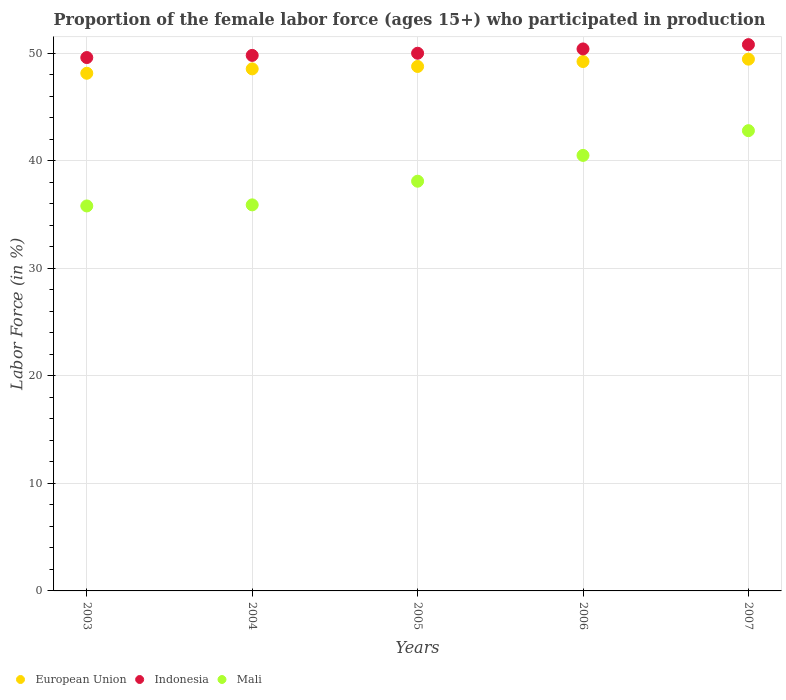How many different coloured dotlines are there?
Provide a short and direct response. 3. What is the proportion of the female labor force who participated in production in European Union in 2003?
Provide a short and direct response. 48.14. Across all years, what is the maximum proportion of the female labor force who participated in production in European Union?
Your answer should be very brief. 49.45. Across all years, what is the minimum proportion of the female labor force who participated in production in European Union?
Keep it short and to the point. 48.14. In which year was the proportion of the female labor force who participated in production in Mali maximum?
Make the answer very short. 2007. What is the total proportion of the female labor force who participated in production in Mali in the graph?
Your answer should be very brief. 193.1. What is the difference between the proportion of the female labor force who participated in production in Mali in 2003 and that in 2006?
Provide a short and direct response. -4.7. What is the difference between the proportion of the female labor force who participated in production in European Union in 2005 and the proportion of the female labor force who participated in production in Indonesia in 2007?
Give a very brief answer. -2.03. What is the average proportion of the female labor force who participated in production in Mali per year?
Your response must be concise. 38.62. In the year 2004, what is the difference between the proportion of the female labor force who participated in production in Indonesia and proportion of the female labor force who participated in production in Mali?
Provide a succinct answer. 13.9. In how many years, is the proportion of the female labor force who participated in production in European Union greater than 22 %?
Offer a very short reply. 5. What is the ratio of the proportion of the female labor force who participated in production in European Union in 2004 to that in 2005?
Provide a succinct answer. 1. Is the difference between the proportion of the female labor force who participated in production in Indonesia in 2005 and 2007 greater than the difference between the proportion of the female labor force who participated in production in Mali in 2005 and 2007?
Keep it short and to the point. Yes. What is the difference between the highest and the second highest proportion of the female labor force who participated in production in Mali?
Provide a succinct answer. 2.3. What is the difference between the highest and the lowest proportion of the female labor force who participated in production in European Union?
Keep it short and to the point. 1.31. Does the proportion of the female labor force who participated in production in European Union monotonically increase over the years?
Ensure brevity in your answer.  Yes. Is the proportion of the female labor force who participated in production in European Union strictly less than the proportion of the female labor force who participated in production in Indonesia over the years?
Provide a short and direct response. Yes. How many years are there in the graph?
Give a very brief answer. 5. What is the difference between two consecutive major ticks on the Y-axis?
Keep it short and to the point. 10. Are the values on the major ticks of Y-axis written in scientific E-notation?
Offer a very short reply. No. Does the graph contain any zero values?
Give a very brief answer. No. How are the legend labels stacked?
Make the answer very short. Horizontal. What is the title of the graph?
Ensure brevity in your answer.  Proportion of the female labor force (ages 15+) who participated in production. What is the label or title of the X-axis?
Provide a succinct answer. Years. What is the Labor Force (in %) of European Union in 2003?
Make the answer very short. 48.14. What is the Labor Force (in %) in Indonesia in 2003?
Give a very brief answer. 49.6. What is the Labor Force (in %) in Mali in 2003?
Your answer should be very brief. 35.8. What is the Labor Force (in %) in European Union in 2004?
Provide a short and direct response. 48.55. What is the Labor Force (in %) in Indonesia in 2004?
Offer a very short reply. 49.8. What is the Labor Force (in %) of Mali in 2004?
Give a very brief answer. 35.9. What is the Labor Force (in %) in European Union in 2005?
Your answer should be compact. 48.77. What is the Labor Force (in %) of Indonesia in 2005?
Offer a terse response. 50. What is the Labor Force (in %) in Mali in 2005?
Offer a terse response. 38.1. What is the Labor Force (in %) of European Union in 2006?
Your answer should be compact. 49.23. What is the Labor Force (in %) of Indonesia in 2006?
Keep it short and to the point. 50.4. What is the Labor Force (in %) of Mali in 2006?
Offer a very short reply. 40.5. What is the Labor Force (in %) in European Union in 2007?
Your answer should be compact. 49.45. What is the Labor Force (in %) of Indonesia in 2007?
Offer a terse response. 50.8. What is the Labor Force (in %) of Mali in 2007?
Ensure brevity in your answer.  42.8. Across all years, what is the maximum Labor Force (in %) of European Union?
Make the answer very short. 49.45. Across all years, what is the maximum Labor Force (in %) in Indonesia?
Your response must be concise. 50.8. Across all years, what is the maximum Labor Force (in %) in Mali?
Your response must be concise. 42.8. Across all years, what is the minimum Labor Force (in %) in European Union?
Your answer should be compact. 48.14. Across all years, what is the minimum Labor Force (in %) in Indonesia?
Make the answer very short. 49.6. Across all years, what is the minimum Labor Force (in %) of Mali?
Provide a short and direct response. 35.8. What is the total Labor Force (in %) of European Union in the graph?
Ensure brevity in your answer.  244.14. What is the total Labor Force (in %) of Indonesia in the graph?
Provide a succinct answer. 250.6. What is the total Labor Force (in %) in Mali in the graph?
Your answer should be compact. 193.1. What is the difference between the Labor Force (in %) of European Union in 2003 and that in 2004?
Provide a succinct answer. -0.41. What is the difference between the Labor Force (in %) in Indonesia in 2003 and that in 2004?
Your response must be concise. -0.2. What is the difference between the Labor Force (in %) of European Union in 2003 and that in 2005?
Offer a very short reply. -0.63. What is the difference between the Labor Force (in %) of Indonesia in 2003 and that in 2005?
Provide a succinct answer. -0.4. What is the difference between the Labor Force (in %) in Mali in 2003 and that in 2005?
Your response must be concise. -2.3. What is the difference between the Labor Force (in %) of European Union in 2003 and that in 2006?
Give a very brief answer. -1.09. What is the difference between the Labor Force (in %) of Mali in 2003 and that in 2006?
Give a very brief answer. -4.7. What is the difference between the Labor Force (in %) in European Union in 2003 and that in 2007?
Offer a very short reply. -1.31. What is the difference between the Labor Force (in %) in European Union in 2004 and that in 2005?
Provide a succinct answer. -0.22. What is the difference between the Labor Force (in %) in Mali in 2004 and that in 2005?
Your response must be concise. -2.2. What is the difference between the Labor Force (in %) in European Union in 2004 and that in 2006?
Make the answer very short. -0.68. What is the difference between the Labor Force (in %) of Indonesia in 2004 and that in 2006?
Offer a terse response. -0.6. What is the difference between the Labor Force (in %) in Mali in 2004 and that in 2006?
Offer a very short reply. -4.6. What is the difference between the Labor Force (in %) in European Union in 2004 and that in 2007?
Make the answer very short. -0.9. What is the difference between the Labor Force (in %) in Mali in 2004 and that in 2007?
Keep it short and to the point. -6.9. What is the difference between the Labor Force (in %) in European Union in 2005 and that in 2006?
Provide a succinct answer. -0.46. What is the difference between the Labor Force (in %) of Indonesia in 2005 and that in 2006?
Your response must be concise. -0.4. What is the difference between the Labor Force (in %) in European Union in 2005 and that in 2007?
Ensure brevity in your answer.  -0.68. What is the difference between the Labor Force (in %) of European Union in 2006 and that in 2007?
Ensure brevity in your answer.  -0.22. What is the difference between the Labor Force (in %) of European Union in 2003 and the Labor Force (in %) of Indonesia in 2004?
Your answer should be compact. -1.66. What is the difference between the Labor Force (in %) in European Union in 2003 and the Labor Force (in %) in Mali in 2004?
Offer a terse response. 12.24. What is the difference between the Labor Force (in %) in Indonesia in 2003 and the Labor Force (in %) in Mali in 2004?
Give a very brief answer. 13.7. What is the difference between the Labor Force (in %) in European Union in 2003 and the Labor Force (in %) in Indonesia in 2005?
Give a very brief answer. -1.86. What is the difference between the Labor Force (in %) in European Union in 2003 and the Labor Force (in %) in Mali in 2005?
Ensure brevity in your answer.  10.04. What is the difference between the Labor Force (in %) of Indonesia in 2003 and the Labor Force (in %) of Mali in 2005?
Provide a succinct answer. 11.5. What is the difference between the Labor Force (in %) of European Union in 2003 and the Labor Force (in %) of Indonesia in 2006?
Ensure brevity in your answer.  -2.26. What is the difference between the Labor Force (in %) in European Union in 2003 and the Labor Force (in %) in Mali in 2006?
Offer a terse response. 7.64. What is the difference between the Labor Force (in %) in Indonesia in 2003 and the Labor Force (in %) in Mali in 2006?
Provide a short and direct response. 9.1. What is the difference between the Labor Force (in %) of European Union in 2003 and the Labor Force (in %) of Indonesia in 2007?
Keep it short and to the point. -2.66. What is the difference between the Labor Force (in %) in European Union in 2003 and the Labor Force (in %) in Mali in 2007?
Your answer should be very brief. 5.34. What is the difference between the Labor Force (in %) in Indonesia in 2003 and the Labor Force (in %) in Mali in 2007?
Offer a very short reply. 6.8. What is the difference between the Labor Force (in %) in European Union in 2004 and the Labor Force (in %) in Indonesia in 2005?
Ensure brevity in your answer.  -1.45. What is the difference between the Labor Force (in %) in European Union in 2004 and the Labor Force (in %) in Mali in 2005?
Offer a very short reply. 10.45. What is the difference between the Labor Force (in %) in Indonesia in 2004 and the Labor Force (in %) in Mali in 2005?
Your answer should be compact. 11.7. What is the difference between the Labor Force (in %) in European Union in 2004 and the Labor Force (in %) in Indonesia in 2006?
Ensure brevity in your answer.  -1.85. What is the difference between the Labor Force (in %) of European Union in 2004 and the Labor Force (in %) of Mali in 2006?
Provide a short and direct response. 8.05. What is the difference between the Labor Force (in %) of Indonesia in 2004 and the Labor Force (in %) of Mali in 2006?
Make the answer very short. 9.3. What is the difference between the Labor Force (in %) of European Union in 2004 and the Labor Force (in %) of Indonesia in 2007?
Your answer should be very brief. -2.25. What is the difference between the Labor Force (in %) of European Union in 2004 and the Labor Force (in %) of Mali in 2007?
Ensure brevity in your answer.  5.75. What is the difference between the Labor Force (in %) of European Union in 2005 and the Labor Force (in %) of Indonesia in 2006?
Keep it short and to the point. -1.63. What is the difference between the Labor Force (in %) of European Union in 2005 and the Labor Force (in %) of Mali in 2006?
Offer a very short reply. 8.27. What is the difference between the Labor Force (in %) in Indonesia in 2005 and the Labor Force (in %) in Mali in 2006?
Provide a succinct answer. 9.5. What is the difference between the Labor Force (in %) in European Union in 2005 and the Labor Force (in %) in Indonesia in 2007?
Your response must be concise. -2.03. What is the difference between the Labor Force (in %) of European Union in 2005 and the Labor Force (in %) of Mali in 2007?
Offer a terse response. 5.97. What is the difference between the Labor Force (in %) in Indonesia in 2005 and the Labor Force (in %) in Mali in 2007?
Ensure brevity in your answer.  7.2. What is the difference between the Labor Force (in %) of European Union in 2006 and the Labor Force (in %) of Indonesia in 2007?
Your response must be concise. -1.57. What is the difference between the Labor Force (in %) of European Union in 2006 and the Labor Force (in %) of Mali in 2007?
Keep it short and to the point. 6.43. What is the difference between the Labor Force (in %) of Indonesia in 2006 and the Labor Force (in %) of Mali in 2007?
Provide a short and direct response. 7.6. What is the average Labor Force (in %) of European Union per year?
Your answer should be compact. 48.83. What is the average Labor Force (in %) of Indonesia per year?
Your response must be concise. 50.12. What is the average Labor Force (in %) of Mali per year?
Make the answer very short. 38.62. In the year 2003, what is the difference between the Labor Force (in %) in European Union and Labor Force (in %) in Indonesia?
Keep it short and to the point. -1.46. In the year 2003, what is the difference between the Labor Force (in %) of European Union and Labor Force (in %) of Mali?
Your response must be concise. 12.34. In the year 2003, what is the difference between the Labor Force (in %) of Indonesia and Labor Force (in %) of Mali?
Make the answer very short. 13.8. In the year 2004, what is the difference between the Labor Force (in %) in European Union and Labor Force (in %) in Indonesia?
Offer a terse response. -1.25. In the year 2004, what is the difference between the Labor Force (in %) in European Union and Labor Force (in %) in Mali?
Your response must be concise. 12.65. In the year 2004, what is the difference between the Labor Force (in %) in Indonesia and Labor Force (in %) in Mali?
Provide a succinct answer. 13.9. In the year 2005, what is the difference between the Labor Force (in %) in European Union and Labor Force (in %) in Indonesia?
Ensure brevity in your answer.  -1.23. In the year 2005, what is the difference between the Labor Force (in %) in European Union and Labor Force (in %) in Mali?
Provide a short and direct response. 10.67. In the year 2005, what is the difference between the Labor Force (in %) in Indonesia and Labor Force (in %) in Mali?
Offer a very short reply. 11.9. In the year 2006, what is the difference between the Labor Force (in %) in European Union and Labor Force (in %) in Indonesia?
Your answer should be compact. -1.17. In the year 2006, what is the difference between the Labor Force (in %) of European Union and Labor Force (in %) of Mali?
Give a very brief answer. 8.73. In the year 2006, what is the difference between the Labor Force (in %) of Indonesia and Labor Force (in %) of Mali?
Your response must be concise. 9.9. In the year 2007, what is the difference between the Labor Force (in %) of European Union and Labor Force (in %) of Indonesia?
Offer a terse response. -1.35. In the year 2007, what is the difference between the Labor Force (in %) of European Union and Labor Force (in %) of Mali?
Your answer should be very brief. 6.65. What is the ratio of the Labor Force (in %) in European Union in 2003 to that in 2005?
Provide a succinct answer. 0.99. What is the ratio of the Labor Force (in %) in Mali in 2003 to that in 2005?
Ensure brevity in your answer.  0.94. What is the ratio of the Labor Force (in %) in European Union in 2003 to that in 2006?
Your answer should be very brief. 0.98. What is the ratio of the Labor Force (in %) in Indonesia in 2003 to that in 2006?
Make the answer very short. 0.98. What is the ratio of the Labor Force (in %) of Mali in 2003 to that in 2006?
Keep it short and to the point. 0.88. What is the ratio of the Labor Force (in %) in European Union in 2003 to that in 2007?
Provide a short and direct response. 0.97. What is the ratio of the Labor Force (in %) of Indonesia in 2003 to that in 2007?
Keep it short and to the point. 0.98. What is the ratio of the Labor Force (in %) in Mali in 2003 to that in 2007?
Provide a succinct answer. 0.84. What is the ratio of the Labor Force (in %) of Indonesia in 2004 to that in 2005?
Provide a succinct answer. 1. What is the ratio of the Labor Force (in %) of Mali in 2004 to that in 2005?
Ensure brevity in your answer.  0.94. What is the ratio of the Labor Force (in %) of European Union in 2004 to that in 2006?
Provide a succinct answer. 0.99. What is the ratio of the Labor Force (in %) in Mali in 2004 to that in 2006?
Keep it short and to the point. 0.89. What is the ratio of the Labor Force (in %) of European Union in 2004 to that in 2007?
Your answer should be very brief. 0.98. What is the ratio of the Labor Force (in %) of Indonesia in 2004 to that in 2007?
Your answer should be very brief. 0.98. What is the ratio of the Labor Force (in %) in Mali in 2004 to that in 2007?
Offer a very short reply. 0.84. What is the ratio of the Labor Force (in %) in Mali in 2005 to that in 2006?
Your answer should be compact. 0.94. What is the ratio of the Labor Force (in %) of European Union in 2005 to that in 2007?
Give a very brief answer. 0.99. What is the ratio of the Labor Force (in %) of Indonesia in 2005 to that in 2007?
Your response must be concise. 0.98. What is the ratio of the Labor Force (in %) in Mali in 2005 to that in 2007?
Your answer should be very brief. 0.89. What is the ratio of the Labor Force (in %) in European Union in 2006 to that in 2007?
Provide a short and direct response. 1. What is the ratio of the Labor Force (in %) of Mali in 2006 to that in 2007?
Ensure brevity in your answer.  0.95. What is the difference between the highest and the second highest Labor Force (in %) in European Union?
Provide a succinct answer. 0.22. What is the difference between the highest and the lowest Labor Force (in %) of European Union?
Make the answer very short. 1.31. What is the difference between the highest and the lowest Labor Force (in %) of Indonesia?
Offer a very short reply. 1.2. 